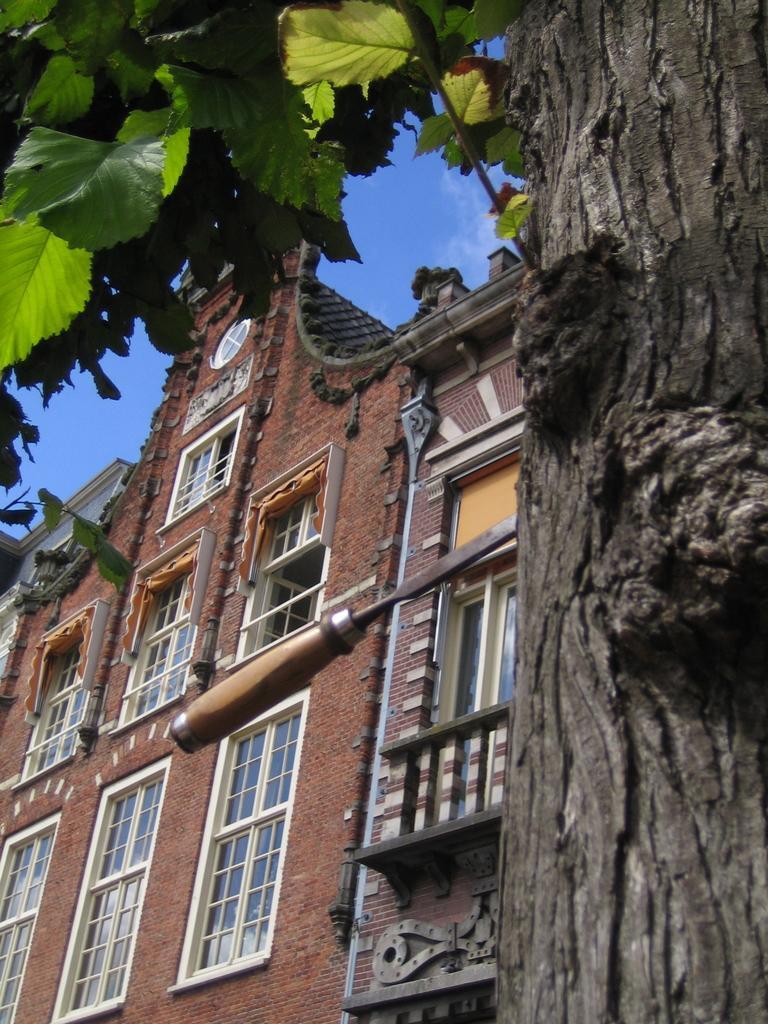Could you give a brief overview of what you see in this image? In this image I can see a tree which is black and green in color and I can see an object to the tree. In the background I can see a building which is brown in color, few windows of the building and the sky. 